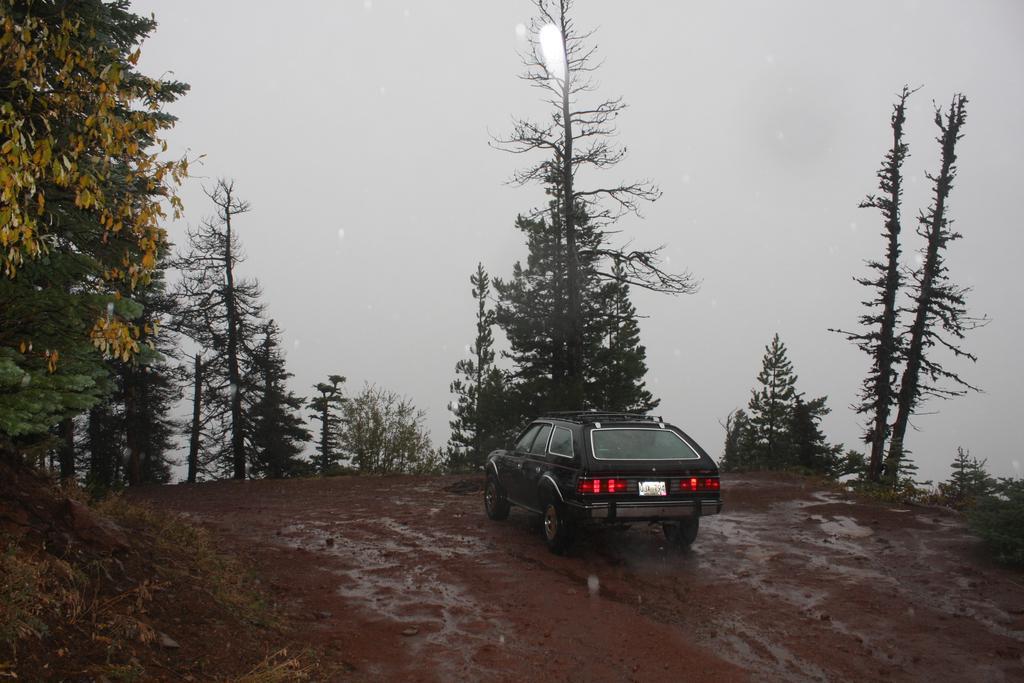Please provide a concise description of this image. In this image we can see a car on a road. On the sides of the road there are trees. In the background it looks like sky. 